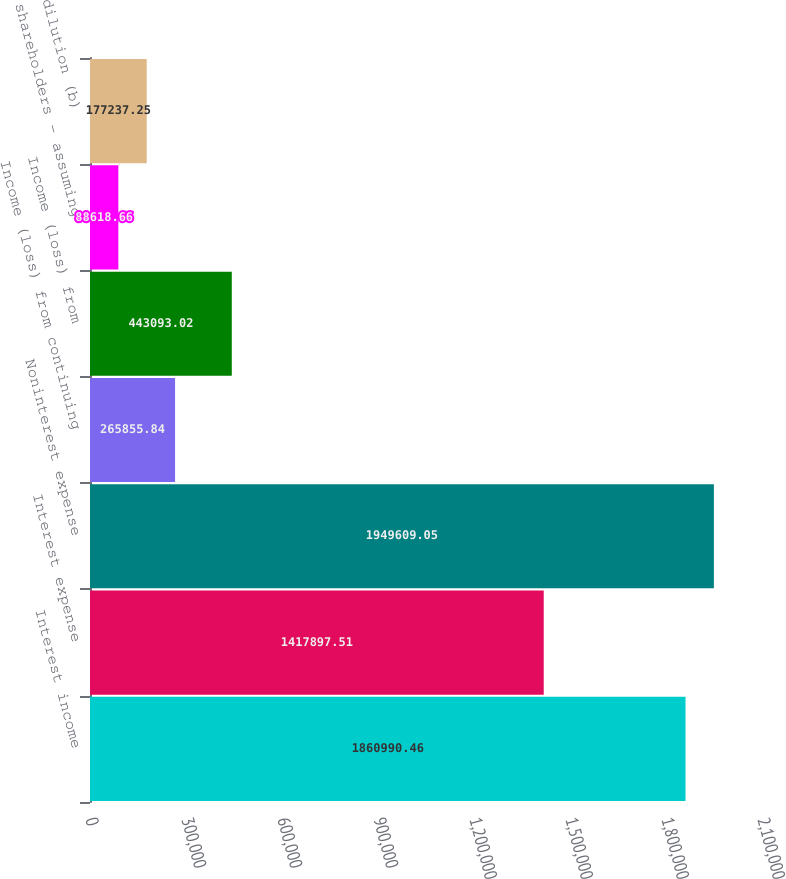Convert chart to OTSL. <chart><loc_0><loc_0><loc_500><loc_500><bar_chart><fcel>Interest income<fcel>Interest expense<fcel>Noninterest expense<fcel>Income (loss) from continuing<fcel>Income (loss) from<fcel>shareholders - assuming<fcel>dilution (b)<nl><fcel>1.86099e+06<fcel>1.4179e+06<fcel>1.94961e+06<fcel>265856<fcel>443093<fcel>88618.7<fcel>177237<nl></chart> 